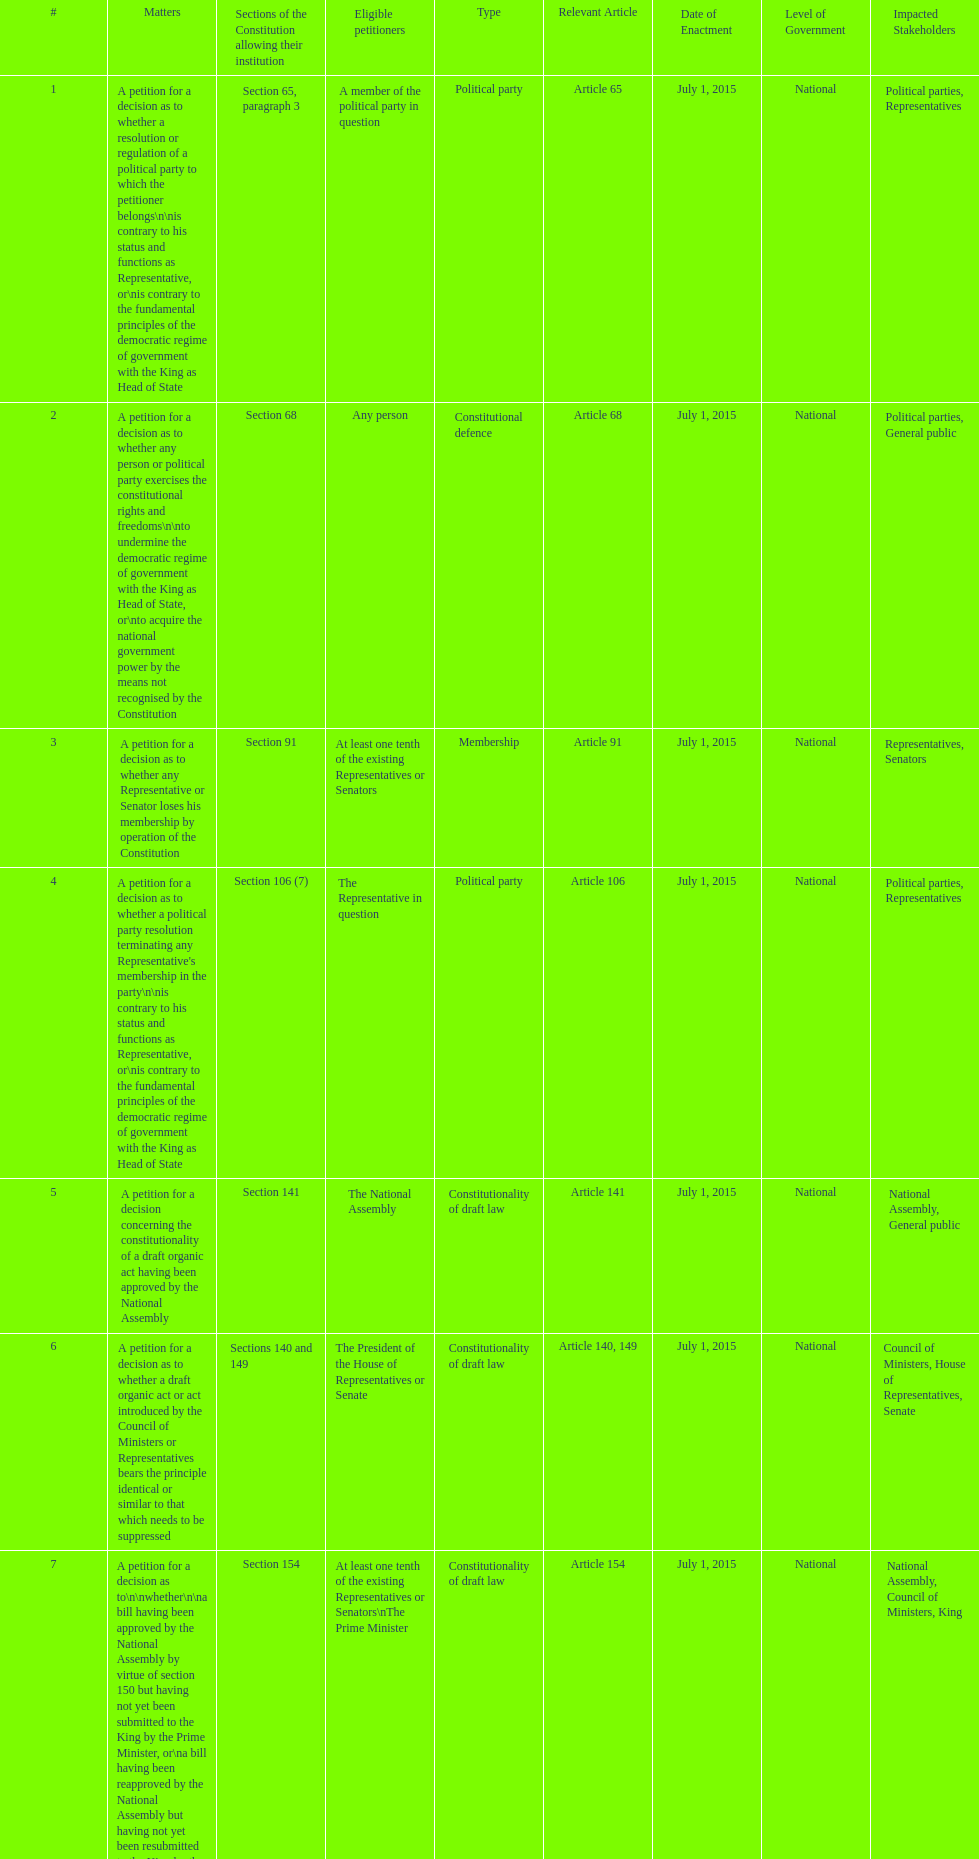How many matters have political party as their "type"? 3. 